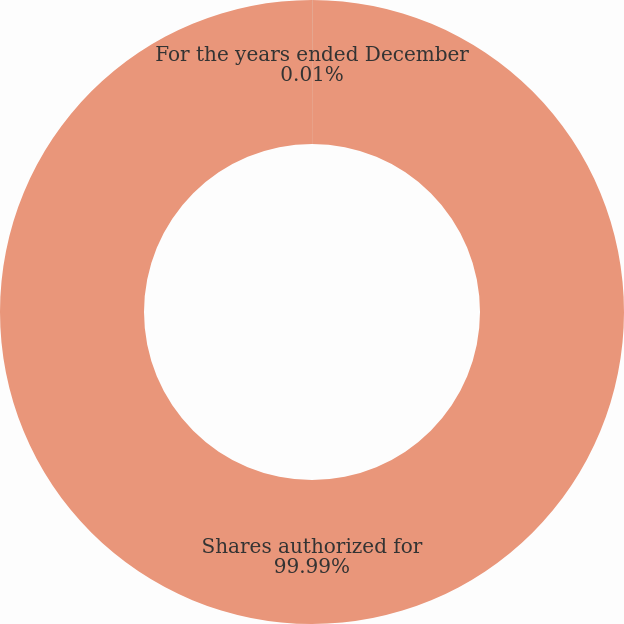Convert chart to OTSL. <chart><loc_0><loc_0><loc_500><loc_500><pie_chart><fcel>For the years ended December<fcel>Shares authorized for<nl><fcel>0.01%<fcel>99.99%<nl></chart> 